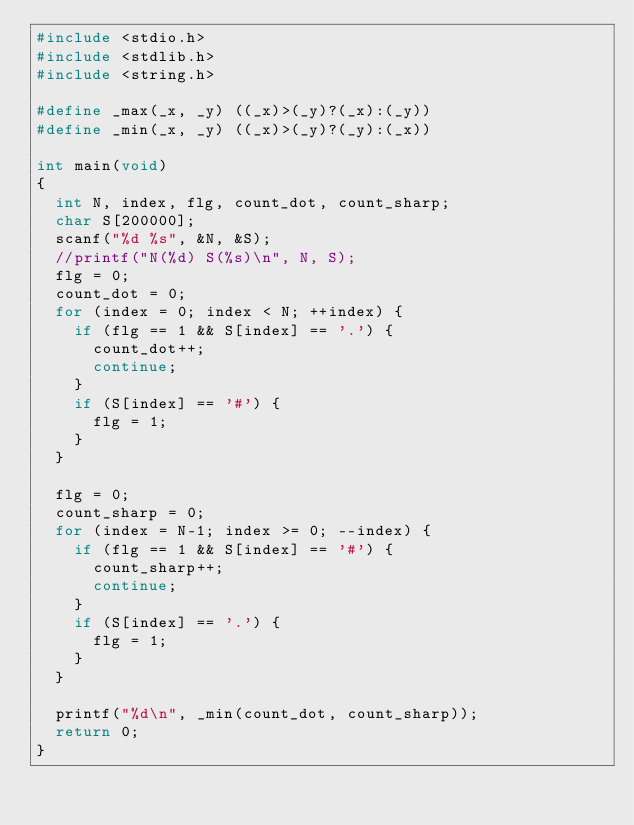Convert code to text. <code><loc_0><loc_0><loc_500><loc_500><_C_>#include <stdio.h>
#include <stdlib.h>
#include <string.h>

#define _max(_x, _y) ((_x)>(_y)?(_x):(_y))
#define _min(_x, _y) ((_x)>(_y)?(_y):(_x))

int main(void)
{
  int N, index, flg, count_dot, count_sharp;
  char S[200000];
  scanf("%d %s", &N, &S);
  //printf("N(%d) S(%s)\n", N, S);
  flg = 0;
  count_dot = 0;
  for (index = 0; index < N; ++index) {
    if (flg == 1 && S[index] == '.') {
      count_dot++;
      continue;
    }
    if (S[index] == '#') {
      flg = 1;
    }
  }
  
  flg = 0;
  count_sharp = 0;
  for (index = N-1; index >= 0; --index) {
    if (flg == 1 && S[index] == '#') {
      count_sharp++;
      continue;
    }
    if (S[index] == '.') {
      flg = 1;
    }
  }
  
  printf("%d\n", _min(count_dot, count_sharp));
  return 0;
}</code> 